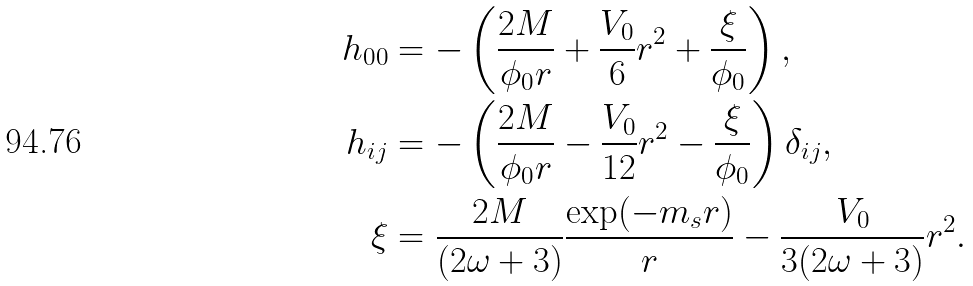<formula> <loc_0><loc_0><loc_500><loc_500>h _ { 0 0 } & = - \left ( \frac { 2 M } { \phi _ { 0 } r } + \frac { V _ { 0 } } { 6 } r ^ { 2 } + \frac { \xi } { \phi _ { 0 } } \right ) , \\ h _ { i j } & = - \left ( \frac { 2 M } { \phi _ { 0 } r } - \frac { V _ { 0 } } { 1 2 } r ^ { 2 } - \frac { \xi } { \phi _ { 0 } } \right ) \delta _ { i j } , \\ \xi & = \frac { 2 M } { ( 2 \omega + 3 ) } \frac { \exp ( - m _ { s } r ) } { r } - \frac { V _ { 0 } } { 3 ( 2 \omega + 3 ) } r ^ { 2 } .</formula> 